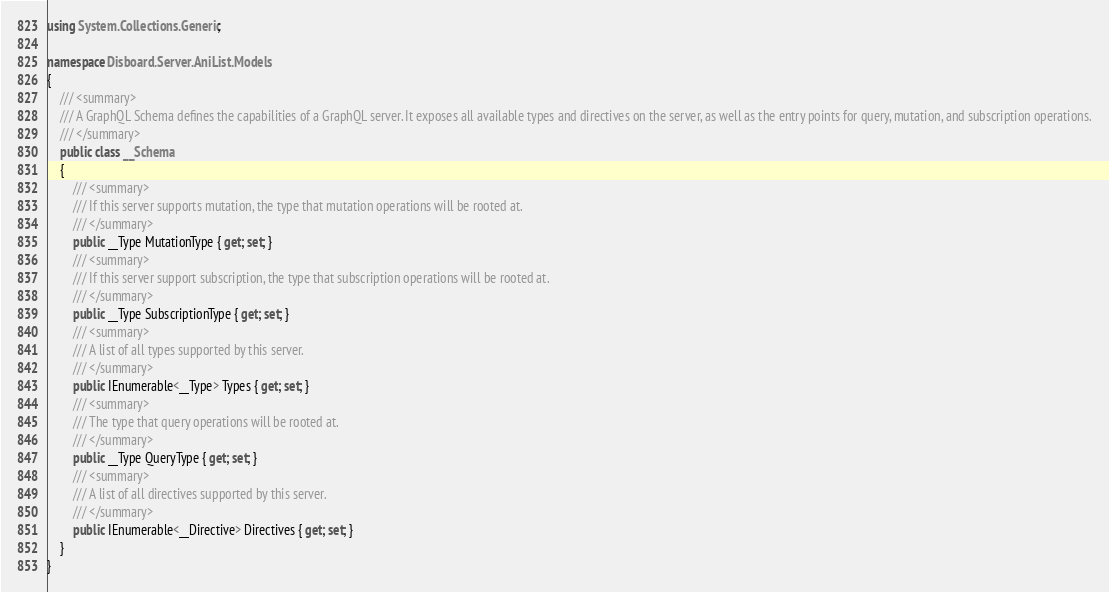Convert code to text. <code><loc_0><loc_0><loc_500><loc_500><_C#_>using System.Collections.Generic;

namespace Disboard.Server.AniList.Models
{
    /// <summary>
    /// A GraphQL Schema defines the capabilities of a GraphQL server. It exposes all available types and directives on the server, as well as the entry points for query, mutation, and subscription operations.
    /// </summary>
    public class __Schema
    {
        /// <summary>
        /// If this server supports mutation, the type that mutation operations will be rooted at.
        /// </summary>
        public __Type MutationType { get; set; }
        /// <summary>
        /// If this server support subscription, the type that subscription operations will be rooted at.
        /// </summary>
        public __Type SubscriptionType { get; set; }
        /// <summary>
        /// A list of all types supported by this server.
        /// </summary>
        public IEnumerable<__Type> Types { get; set; }
        /// <summary>
        /// The type that query operations will be rooted at.
        /// </summary>
        public __Type QueryType { get; set; }
        /// <summary>
        /// A list of all directives supported by this server.
        /// </summary>
        public IEnumerable<__Directive> Directives { get; set; }
    }
}
</code> 